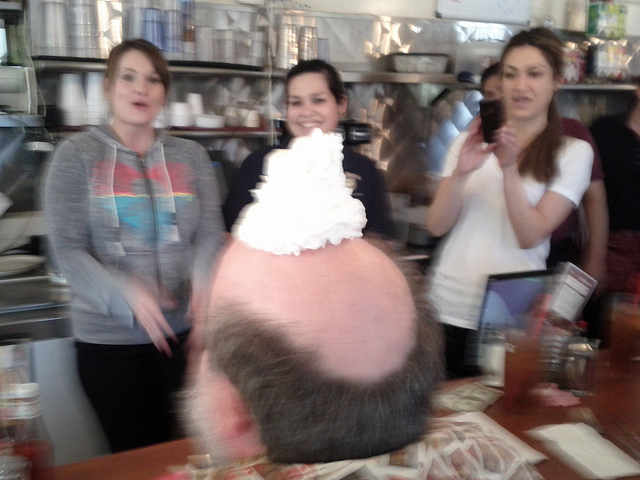What does the woman do with her phone? Based on the image, the woman is capturing a light-hearted moment by taking a photo with her phone. This candid scene appears to be happening in a social setting, possibly a restaurant, where a man is humorously sporting a tall dollop of whipped cream on his head. 